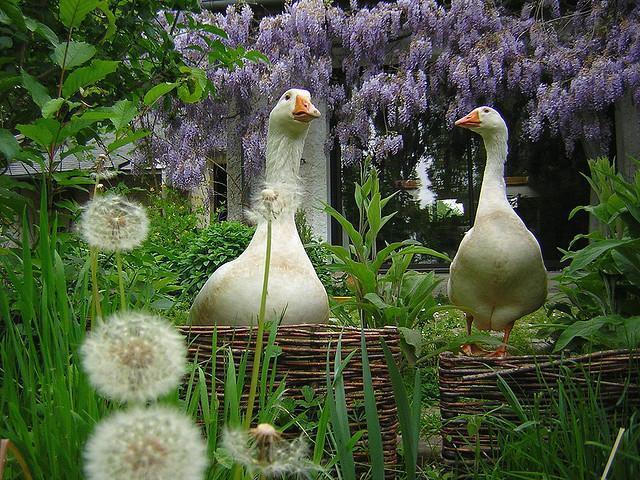How many ducks can be seen?
Give a very brief answer. 2. How many birds are there?
Give a very brief answer. 2. 